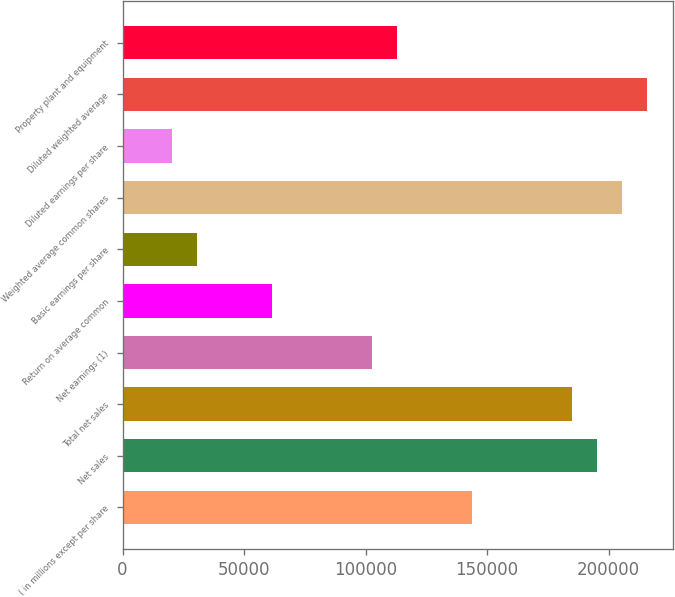Convert chart. <chart><loc_0><loc_0><loc_500><loc_500><bar_chart><fcel>( in millions except per share<fcel>Net sales<fcel>Total net sales<fcel>Net earnings (1)<fcel>Return on average common<fcel>Basic earnings per share<fcel>Weighted average common shares<fcel>Diluted earnings per share<fcel>Diluted weighted average<fcel>Property plant and equipment<nl><fcel>143864<fcel>195244<fcel>184968<fcel>102760<fcel>61656.2<fcel>30828.3<fcel>205520<fcel>20552.3<fcel>215796<fcel>113036<nl></chart> 